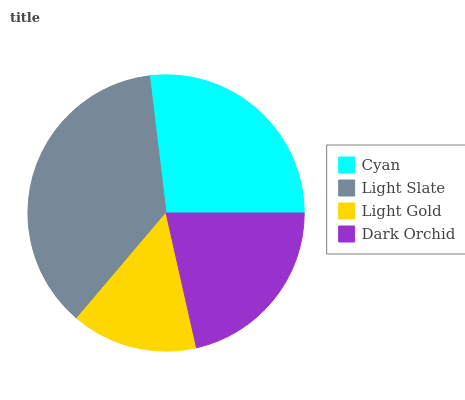Is Light Gold the minimum?
Answer yes or no. Yes. Is Light Slate the maximum?
Answer yes or no. Yes. Is Light Slate the minimum?
Answer yes or no. No. Is Light Gold the maximum?
Answer yes or no. No. Is Light Slate greater than Light Gold?
Answer yes or no. Yes. Is Light Gold less than Light Slate?
Answer yes or no. Yes. Is Light Gold greater than Light Slate?
Answer yes or no. No. Is Light Slate less than Light Gold?
Answer yes or no. No. Is Cyan the high median?
Answer yes or no. Yes. Is Dark Orchid the low median?
Answer yes or no. Yes. Is Light Slate the high median?
Answer yes or no. No. Is Cyan the low median?
Answer yes or no. No. 